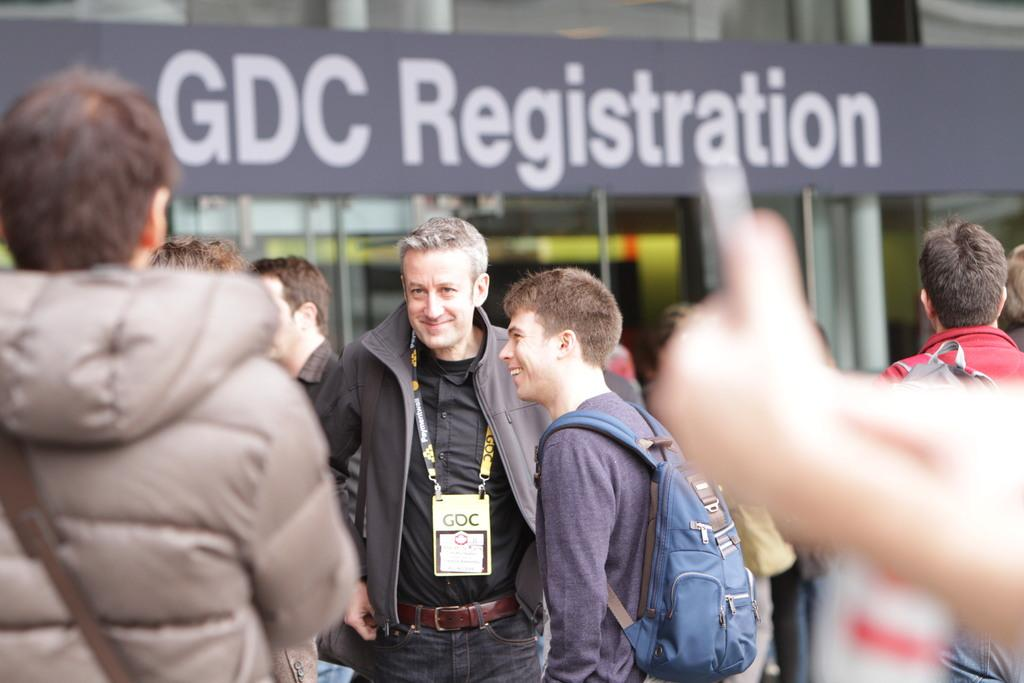What are the people in the image doing? There are people standing in the image. What items are some of the people carrying? Some people are carrying backpacks. Can you describe the man's attire in the image? A man is wearing an identity card. What is written or displayed on the board in the image? There is a board with text in the image. What type of structure can be seen in the background? There is a building in the image. What type of insect is crawling on the tent in the image? There is no tent or insect present in the image. How does the sleet affect the people standing in the image? There is no mention of sleet in the image; the weather or environmental conditions are not specified. 